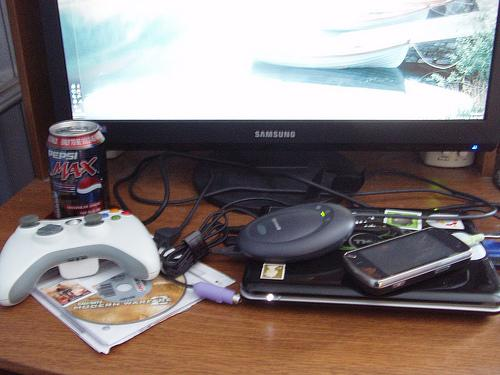Mention one gaming accessory visible in the image and describe its color and buttons. A white and grey video game controller with red, orange, blue, and green buttons is visible in the image. Describe any image visible on the computer monitor in the scene. There is an image of a boat tied to a dock on the computer monitor. What kind of object is next to the Pepsi Max can on the table, and how is it placed? A video game CD is next to the Pepsi Max can, placed in a plastic case. Identify the electronic device located at the top-left corner of the image. A Samsung computer monitor is on the top-left corner of the image. Explain the context of the image, relating it to its elements and their position. The image depicts a workspace with a light brown table, a computer monitor displaying a boat, a plugged-in cellphone, a video game controller, a can of Pepsi Max, a CD, and wires spread across the table. Give a short description of the table's appearance and the objects on it. The table is light brown with electronics such as a computer monitor, cellphone, game controller, a can of soft drink, and wires on top of it. What type of drink container is present on the table and what does it say on it? There is an aluminum soft drink container of Pepsi Max on the table. 